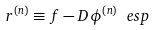<formula> <loc_0><loc_0><loc_500><loc_500>r ^ { ( n ) } \equiv f - D \phi ^ { ( n ) } \ e s p</formula> 